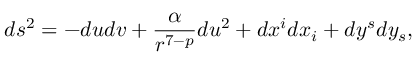<formula> <loc_0><loc_0><loc_500><loc_500>d s ^ { 2 } = - d u d v + \frac { \alpha } { r ^ { 7 - p } } d u ^ { 2 } + d x ^ { i } d x _ { i } + d y ^ { s } d y _ { s } ,</formula> 